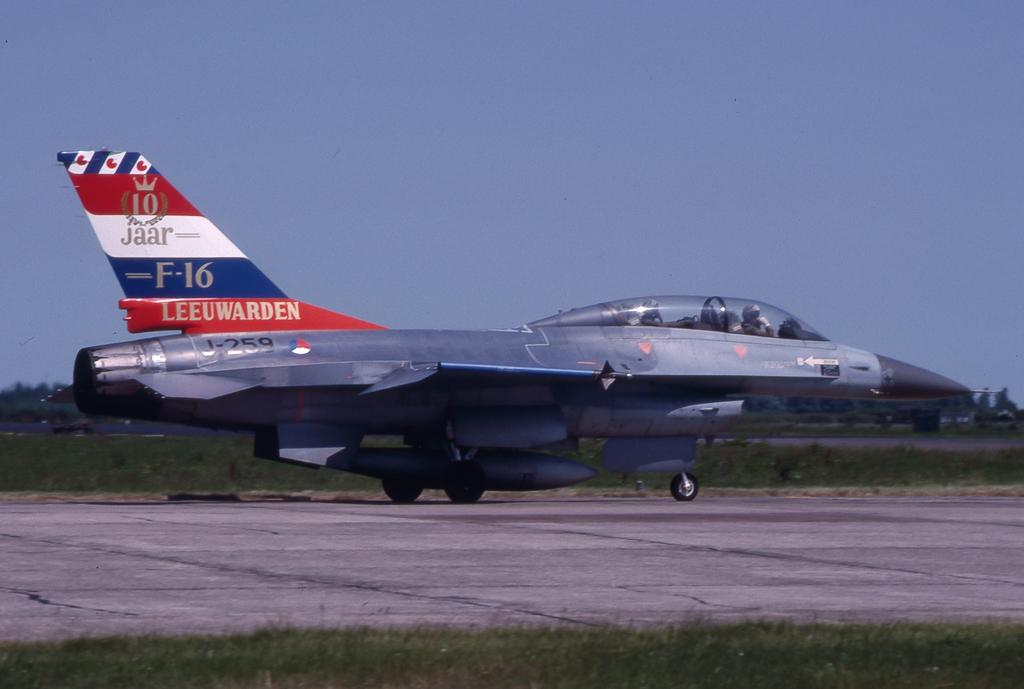<image>
Write a terse but informative summary of the picture. An F-16 fighter jet is taxiing on a runway. 